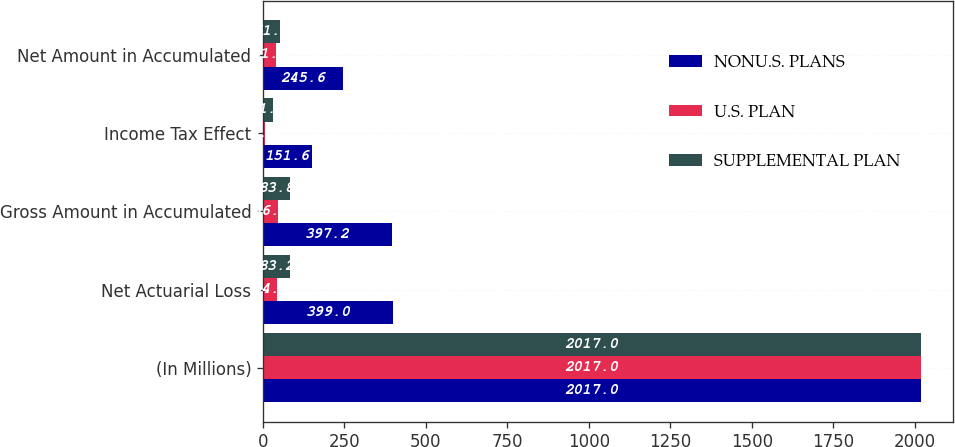<chart> <loc_0><loc_0><loc_500><loc_500><stacked_bar_chart><ecel><fcel>(In Millions)<fcel>Net Actuarial Loss<fcel>Gross Amount in Accumulated<fcel>Income Tax Effect<fcel>Net Amount in Accumulated<nl><fcel>NONU.S. PLANS<fcel>2017<fcel>399<fcel>397.2<fcel>151.6<fcel>245.6<nl><fcel>U.S. PLAN<fcel>2017<fcel>44.2<fcel>46.7<fcel>5.3<fcel>41.4<nl><fcel>SUPPLEMENTAL PLAN<fcel>2017<fcel>83.2<fcel>83.8<fcel>31.9<fcel>51.9<nl></chart> 